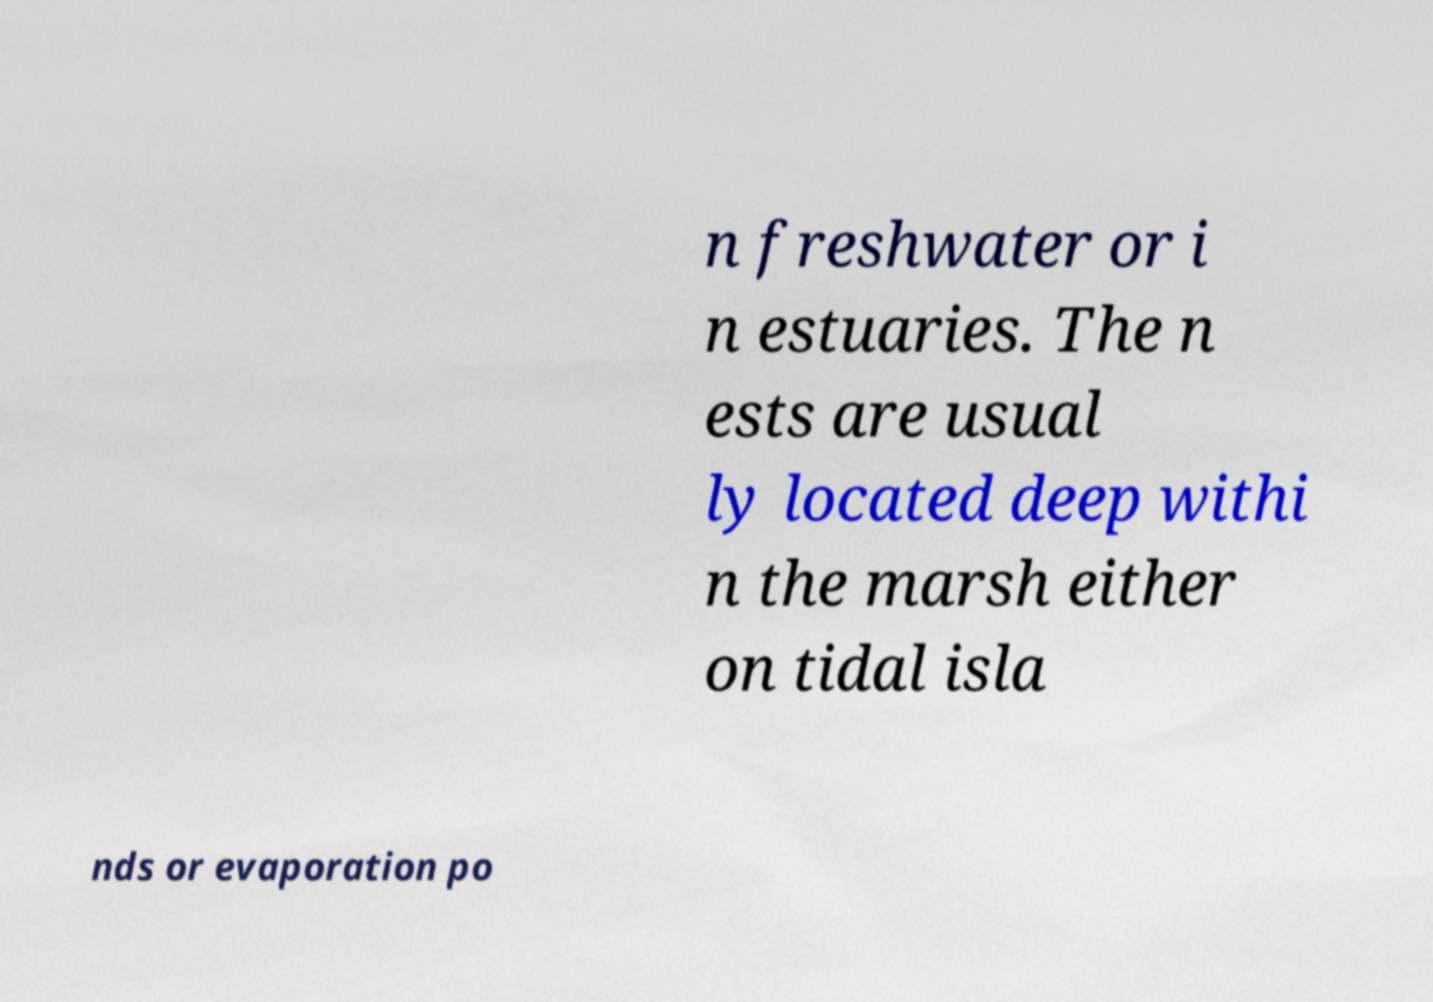What messages or text are displayed in this image? I need them in a readable, typed format. n freshwater or i n estuaries. The n ests are usual ly located deep withi n the marsh either on tidal isla nds or evaporation po 